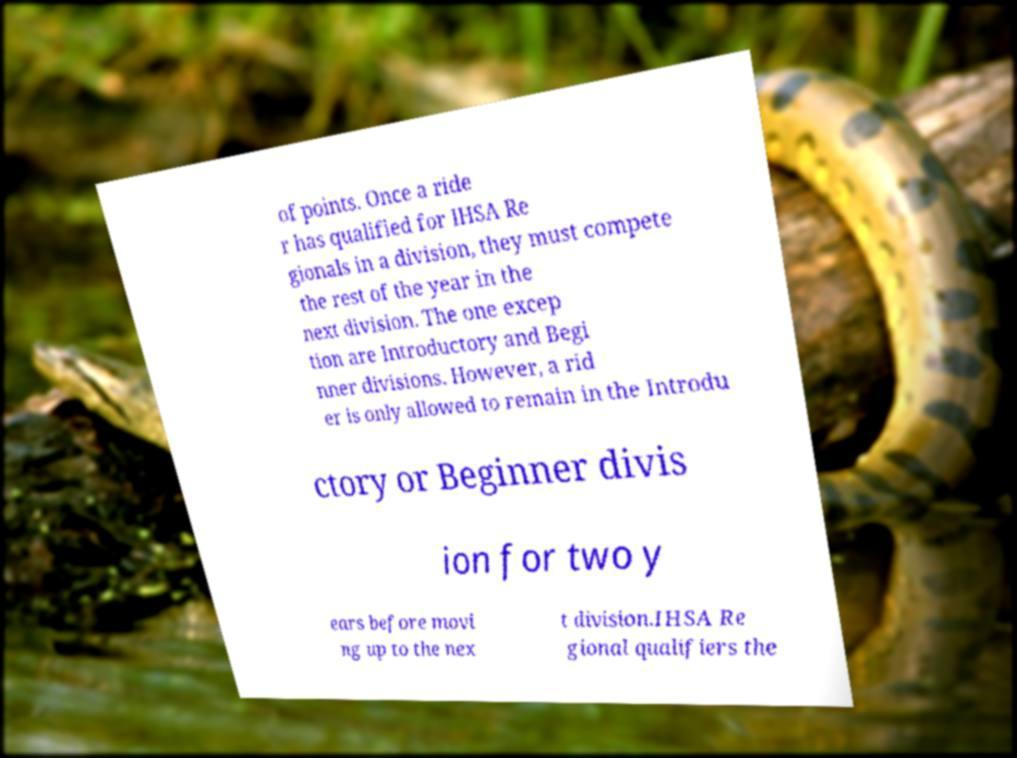Please identify and transcribe the text found in this image. of points. Once a ride r has qualified for IHSA Re gionals in a division, they must compete the rest of the year in the next division. The one excep tion are Introductory and Begi nner divisions. However, a rid er is only allowed to remain in the Introdu ctory or Beginner divis ion for two y ears before movi ng up to the nex t division.IHSA Re gional qualifiers the 